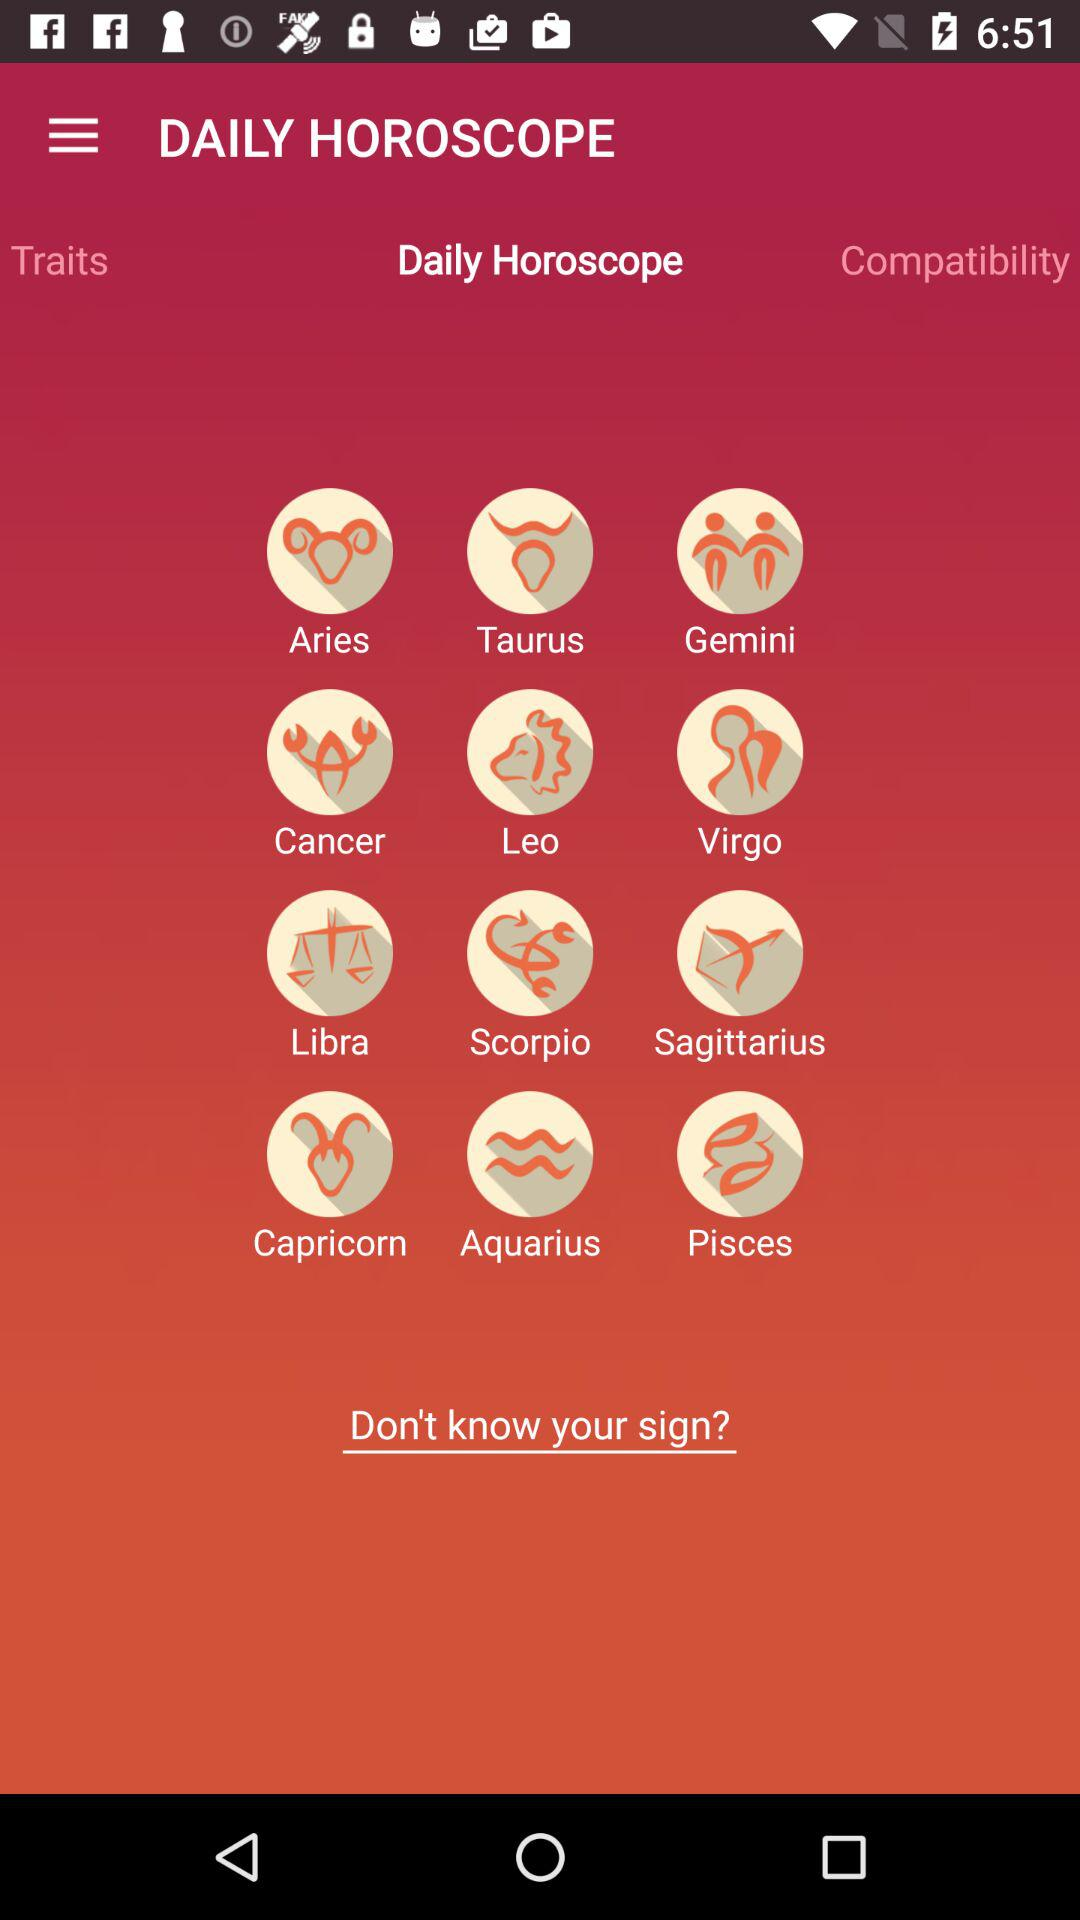What is the name of the application? The application name is "DAILY HOROSCOPE". 